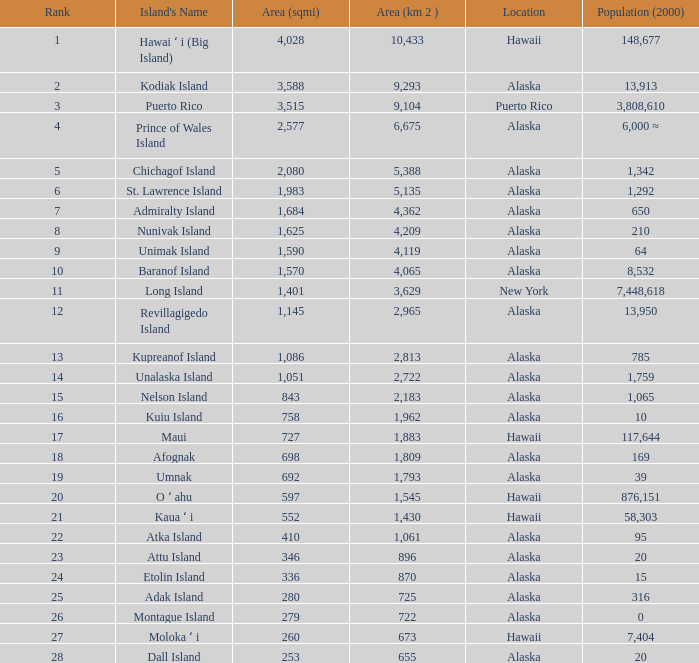What is the highest rank for Nelson Island with area more than 2,183? None. 